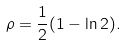<formula> <loc_0><loc_0><loc_500><loc_500>\rho = \frac { 1 } { 2 } ( 1 - \ln 2 ) .</formula> 